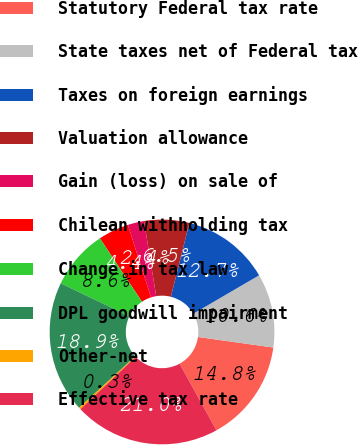Convert chart to OTSL. <chart><loc_0><loc_0><loc_500><loc_500><pie_chart><fcel>Statutory Federal tax rate<fcel>State taxes net of Federal tax<fcel>Taxes on foreign earnings<fcel>Valuation allowance<fcel>Gain (loss) on sale of<fcel>Chilean withholding tax<fcel>Change in tax law<fcel>DPL goodwill impairment<fcel>Other-net<fcel>Effective tax rate<nl><fcel>14.75%<fcel>10.62%<fcel>12.68%<fcel>6.48%<fcel>2.35%<fcel>4.41%<fcel>8.55%<fcel>18.9%<fcel>0.28%<fcel>20.97%<nl></chart> 